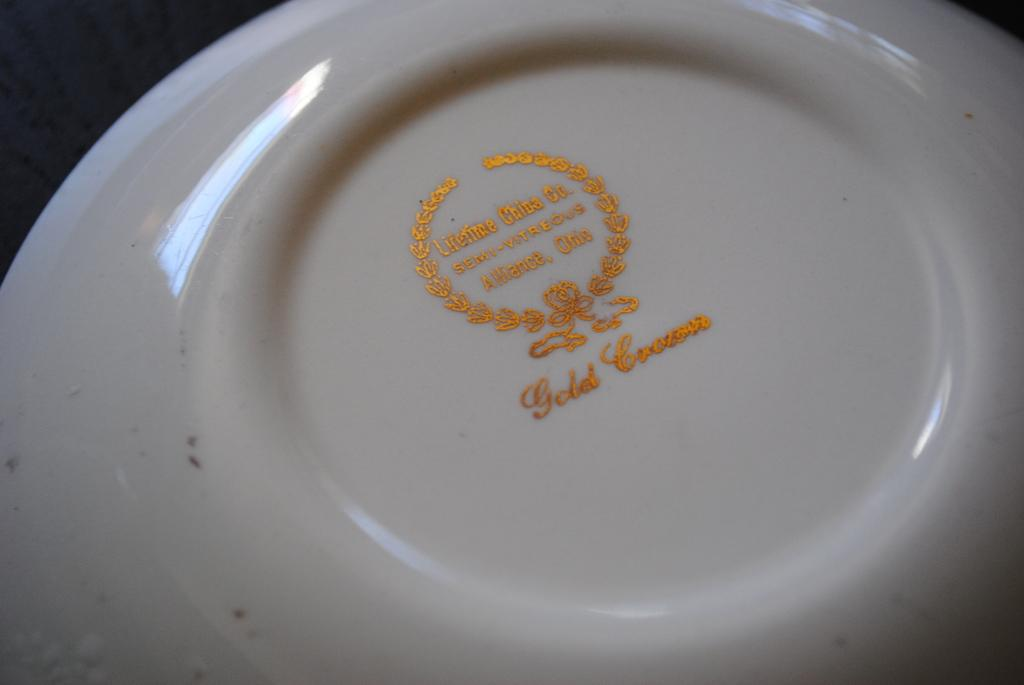What is present on the surface in the image? There is a plate in the image. What color is the plate? The plate is white in color. What is the color of the surface the plate is on? The plate is on a black colored surface. What can be seen printed on the plate? There is something printed on the plate with gold color. Are there any snakes visible on the plate in the image? No, there are no snakes visible on the plate in the image. Is there a cable attached to the plate in the image? No, there is no cable attached to the plate in the image. 